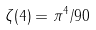Convert formula to latex. <formula><loc_0><loc_0><loc_500><loc_500>\zeta ( 4 ) = \pi ^ { 4 } / 9 0</formula> 